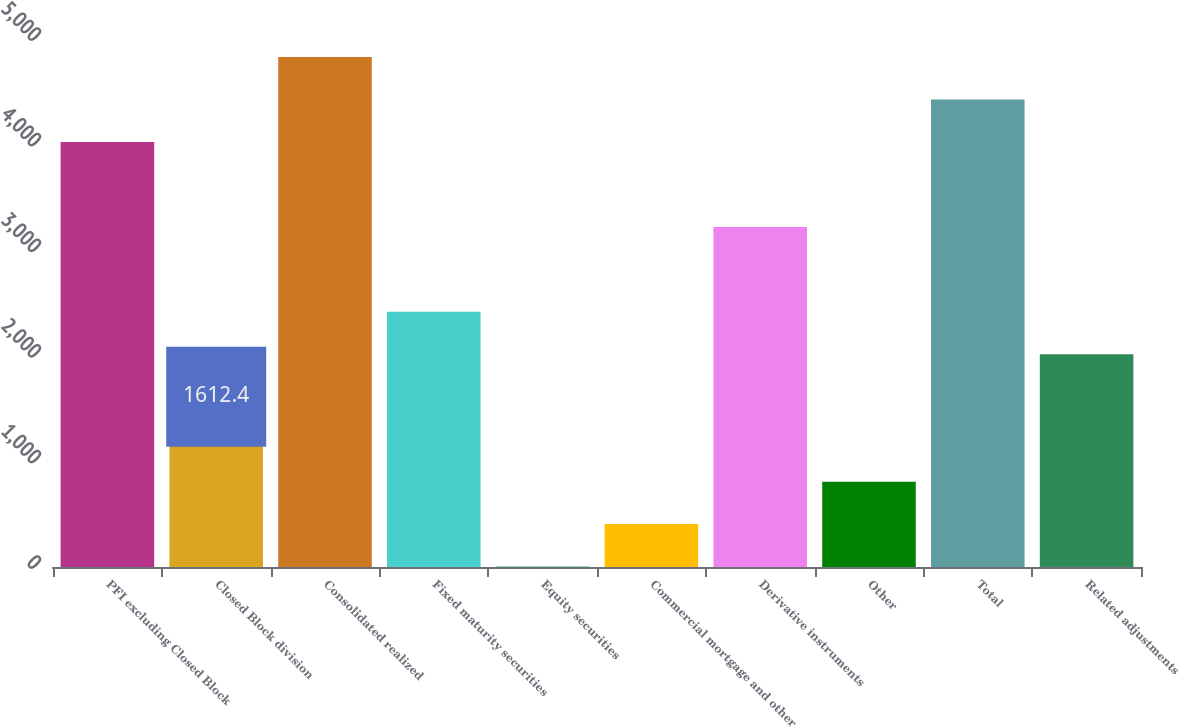<chart> <loc_0><loc_0><loc_500><loc_500><bar_chart><fcel>PFI excluding Closed Block<fcel>Closed Block division<fcel>Consolidated realized<fcel>Fixed maturity securities<fcel>Equity securities<fcel>Commercial mortgage and other<fcel>Derivative instruments<fcel>Other<fcel>Total<fcel>Related adjustments<nl><fcel>4025<fcel>1612.4<fcel>4829.2<fcel>2416.6<fcel>4<fcel>406.1<fcel>3220.8<fcel>808.2<fcel>4427.1<fcel>2014.5<nl></chart> 